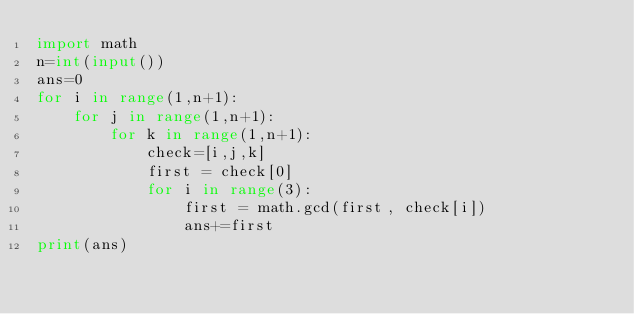Convert code to text. <code><loc_0><loc_0><loc_500><loc_500><_Python_>import math
n=int(input())
ans=0
for i in range(1,n+1):
    for j in range(1,n+1):
        for k in range(1,n+1):
            check=[i,j,k]
            first = check[0]
            for i in range(3):
                first = math.gcd(first, check[i])
                ans+=first
print(ans)  </code> 